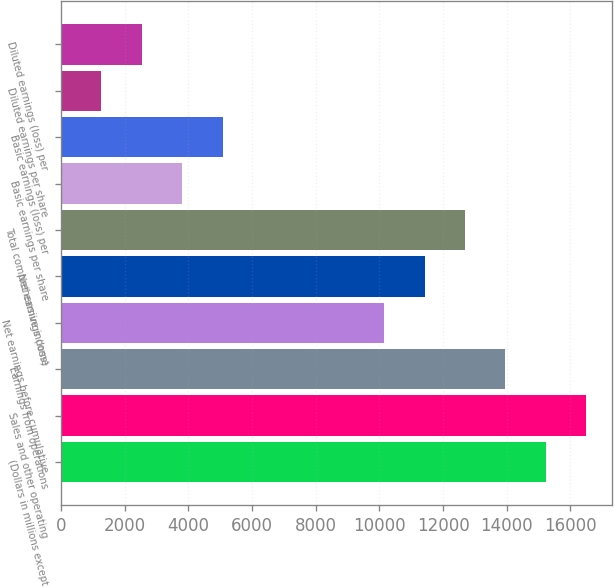Convert chart. <chart><loc_0><loc_0><loc_500><loc_500><bar_chart><fcel>(Dollars in millions except<fcel>Sales and other operating<fcel>Earnings from operations<fcel>Net earnings before cumulative<fcel>Net earnings (loss)<fcel>Total comprehensive income<fcel>Basic earnings per share<fcel>Basic earnings (loss) per<fcel>Diluted earnings per share<fcel>Diluted earnings (loss) per<nl><fcel>15227.9<fcel>16496.9<fcel>13959<fcel>10152<fcel>11421<fcel>12690<fcel>3807.11<fcel>5076.09<fcel>1269.15<fcel>2538.13<nl></chart> 